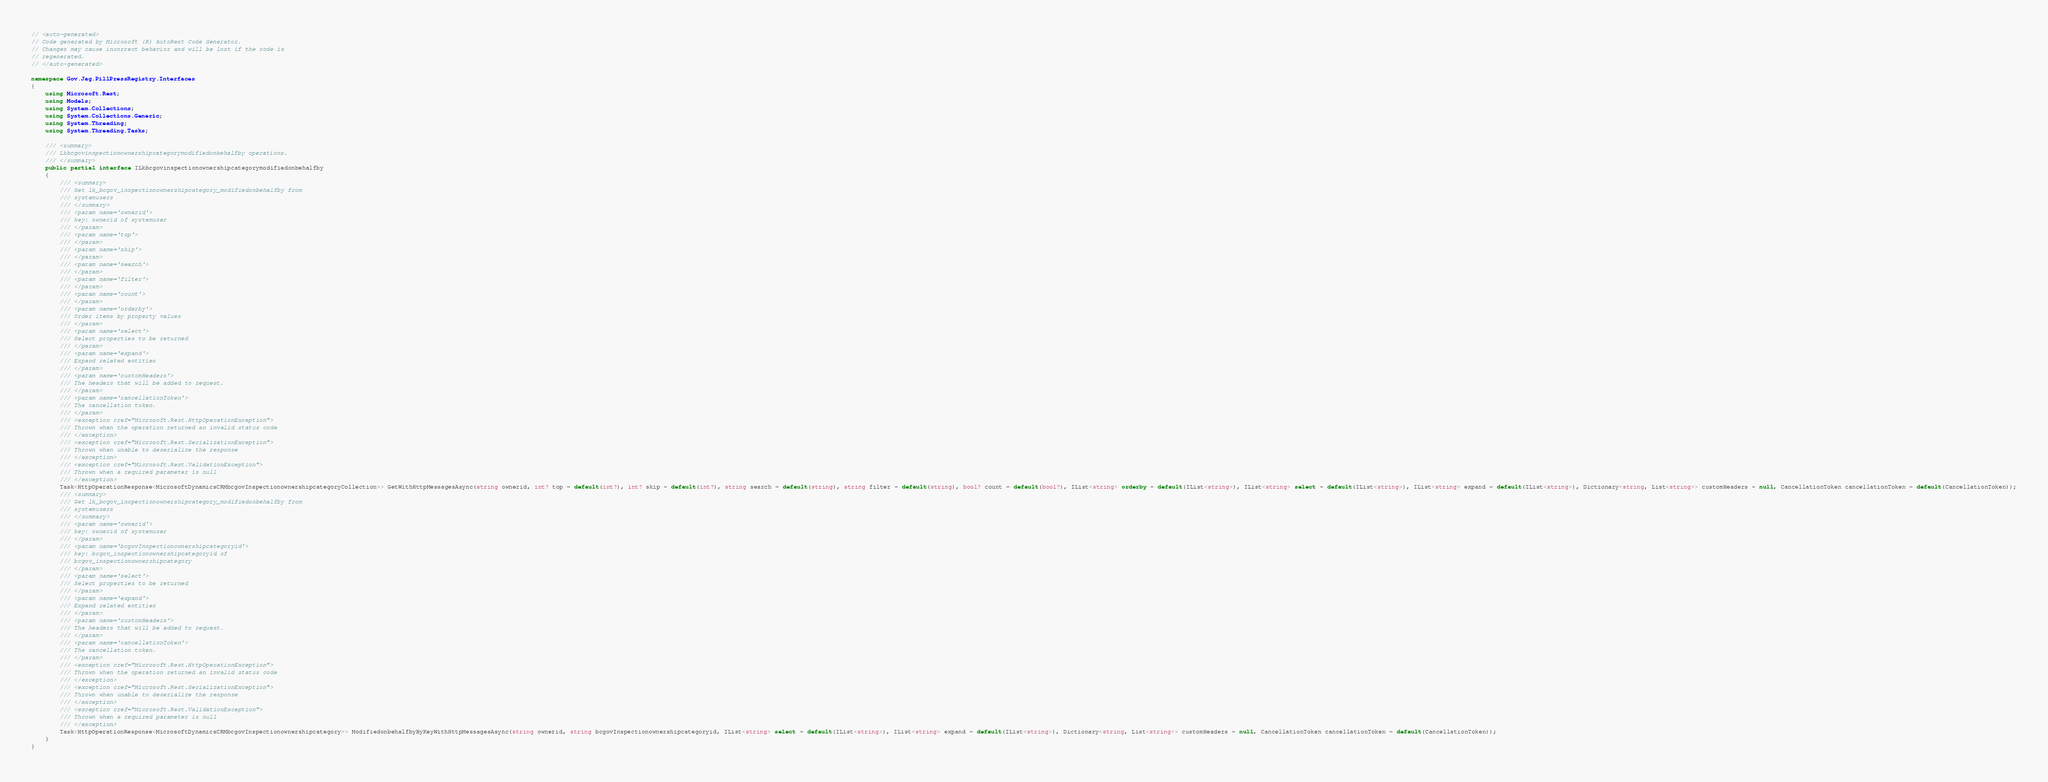<code> <loc_0><loc_0><loc_500><loc_500><_C#_>// <auto-generated>
// Code generated by Microsoft (R) AutoRest Code Generator.
// Changes may cause incorrect behavior and will be lost if the code is
// regenerated.
// </auto-generated>

namespace Gov.Jag.PillPressRegistry.Interfaces
{
    using Microsoft.Rest;
    using Models;
    using System.Collections;
    using System.Collections.Generic;
    using System.Threading;
    using System.Threading.Tasks;

    /// <summary>
    /// Lkbcgovinspectionownershipcategorymodifiedonbehalfby operations.
    /// </summary>
    public partial interface ILkbcgovinspectionownershipcategorymodifiedonbehalfby
    {
        /// <summary>
        /// Get lk_bcgov_inspectionownershipcategory_modifiedonbehalfby from
        /// systemusers
        /// </summary>
        /// <param name='ownerid'>
        /// key: ownerid of systemuser
        /// </param>
        /// <param name='top'>
        /// </param>
        /// <param name='skip'>
        /// </param>
        /// <param name='search'>
        /// </param>
        /// <param name='filter'>
        /// </param>
        /// <param name='count'>
        /// </param>
        /// <param name='orderby'>
        /// Order items by property values
        /// </param>
        /// <param name='select'>
        /// Select properties to be returned
        /// </param>
        /// <param name='expand'>
        /// Expand related entities
        /// </param>
        /// <param name='customHeaders'>
        /// The headers that will be added to request.
        /// </param>
        /// <param name='cancellationToken'>
        /// The cancellation token.
        /// </param>
        /// <exception cref="Microsoft.Rest.HttpOperationException">
        /// Thrown when the operation returned an invalid status code
        /// </exception>
        /// <exception cref="Microsoft.Rest.SerializationException">
        /// Thrown when unable to deserialize the response
        /// </exception>
        /// <exception cref="Microsoft.Rest.ValidationException">
        /// Thrown when a required parameter is null
        /// </exception>
        Task<HttpOperationResponse<MicrosoftDynamicsCRMbcgovInspectionownershipcategoryCollection>> GetWithHttpMessagesAsync(string ownerid, int? top = default(int?), int? skip = default(int?), string search = default(string), string filter = default(string), bool? count = default(bool?), IList<string> orderby = default(IList<string>), IList<string> select = default(IList<string>), IList<string> expand = default(IList<string>), Dictionary<string, List<string>> customHeaders = null, CancellationToken cancellationToken = default(CancellationToken));
        /// <summary>
        /// Get lk_bcgov_inspectionownershipcategory_modifiedonbehalfby from
        /// systemusers
        /// </summary>
        /// <param name='ownerid'>
        /// key: ownerid of systemuser
        /// </param>
        /// <param name='bcgovInspectionownershipcategoryid'>
        /// key: bcgov_inspectionownershipcategoryid of
        /// bcgov_inspectionownershipcategory
        /// </param>
        /// <param name='select'>
        /// Select properties to be returned
        /// </param>
        /// <param name='expand'>
        /// Expand related entities
        /// </param>
        /// <param name='customHeaders'>
        /// The headers that will be added to request.
        /// </param>
        /// <param name='cancellationToken'>
        /// The cancellation token.
        /// </param>
        /// <exception cref="Microsoft.Rest.HttpOperationException">
        /// Thrown when the operation returned an invalid status code
        /// </exception>
        /// <exception cref="Microsoft.Rest.SerializationException">
        /// Thrown when unable to deserialize the response
        /// </exception>
        /// <exception cref="Microsoft.Rest.ValidationException">
        /// Thrown when a required parameter is null
        /// </exception>
        Task<HttpOperationResponse<MicrosoftDynamicsCRMbcgovInspectionownershipcategory>> ModifiedonbehalfbyByKeyWithHttpMessagesAsync(string ownerid, string bcgovInspectionownershipcategoryid, IList<string> select = default(IList<string>), IList<string> expand = default(IList<string>), Dictionary<string, List<string>> customHeaders = null, CancellationToken cancellationToken = default(CancellationToken));
    }
}
</code> 